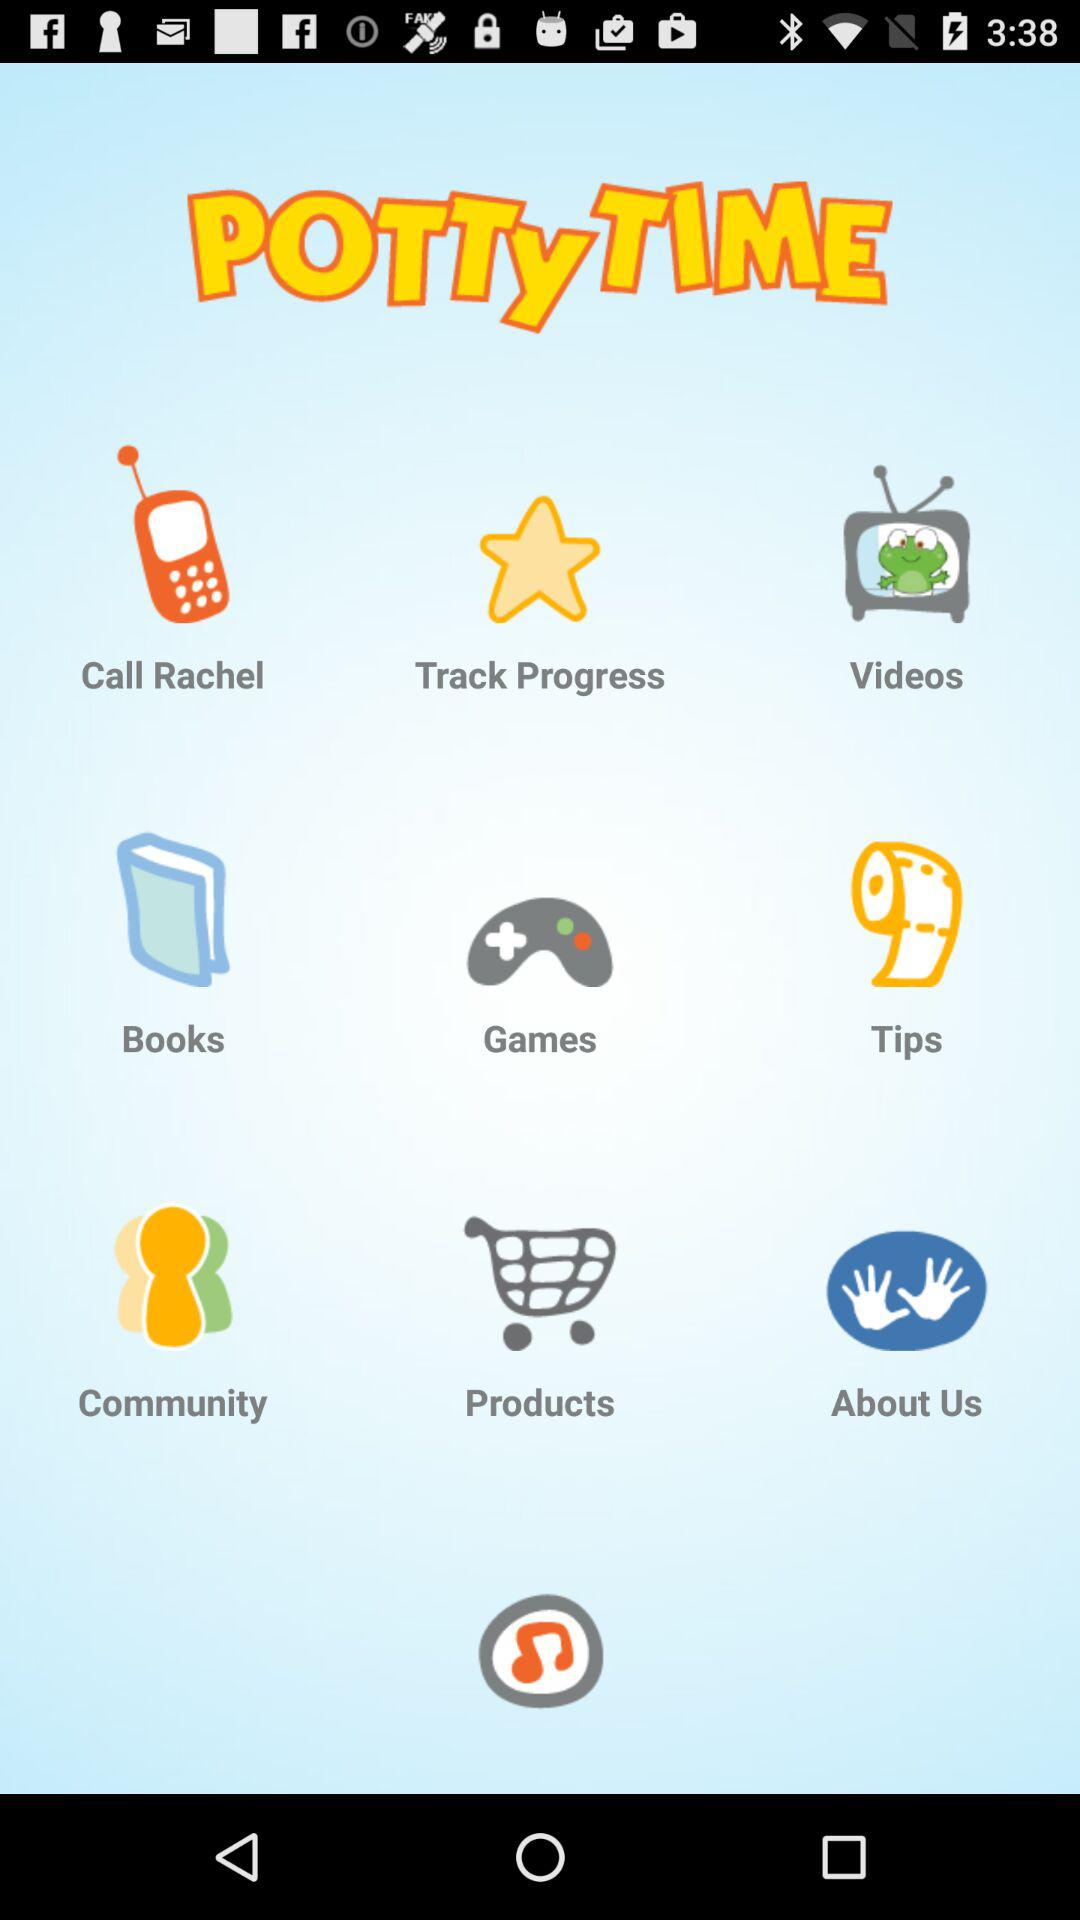What is the name of the application? The name of the application is "POTTYTIME". 